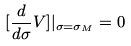<formula> <loc_0><loc_0><loc_500><loc_500>[ \frac { d } { d \sigma } V ] | _ { \sigma = \sigma _ { M } } = 0</formula> 